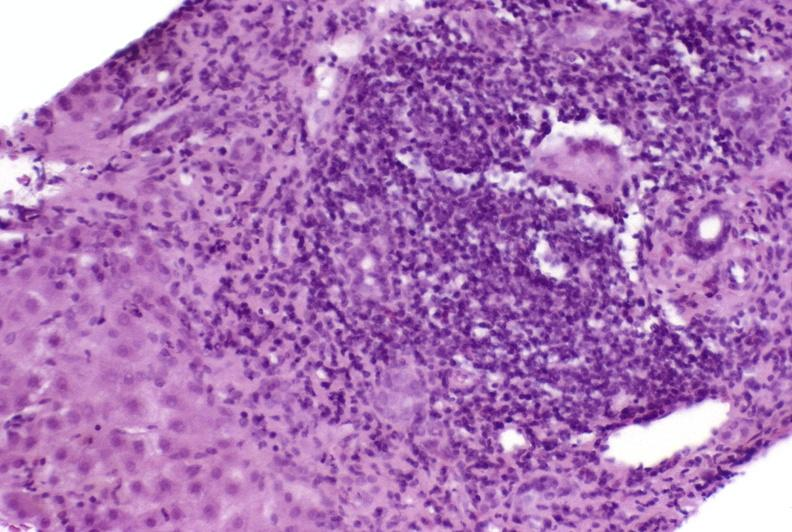what does this image show?
Answer the question using a single word or phrase. Autoimmune hepatitis 